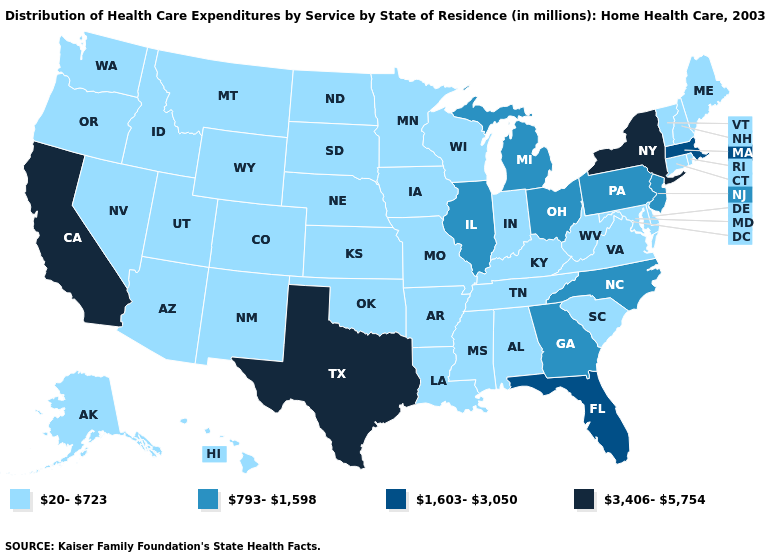What is the highest value in states that border Texas?
Write a very short answer. 20-723. What is the value of Oklahoma?
Quick response, please. 20-723. Name the states that have a value in the range 1,603-3,050?
Quick response, please. Florida, Massachusetts. What is the value of West Virginia?
Be succinct. 20-723. Name the states that have a value in the range 20-723?
Answer briefly. Alabama, Alaska, Arizona, Arkansas, Colorado, Connecticut, Delaware, Hawaii, Idaho, Indiana, Iowa, Kansas, Kentucky, Louisiana, Maine, Maryland, Minnesota, Mississippi, Missouri, Montana, Nebraska, Nevada, New Hampshire, New Mexico, North Dakota, Oklahoma, Oregon, Rhode Island, South Carolina, South Dakota, Tennessee, Utah, Vermont, Virginia, Washington, West Virginia, Wisconsin, Wyoming. What is the value of Michigan?
Quick response, please. 793-1,598. Does New York have the highest value in the Northeast?
Quick response, please. Yes. Does the map have missing data?
Short answer required. No. How many symbols are there in the legend?
Quick response, please. 4. Among the states that border Ohio , does West Virginia have the highest value?
Keep it brief. No. Name the states that have a value in the range 793-1,598?
Quick response, please. Georgia, Illinois, Michigan, New Jersey, North Carolina, Ohio, Pennsylvania. Does Indiana have a lower value than California?
Quick response, please. Yes. Does Florida have the same value as Massachusetts?
Short answer required. Yes. Does Utah have a lower value than North Carolina?
Answer briefly. Yes. What is the value of West Virginia?
Keep it brief. 20-723. 